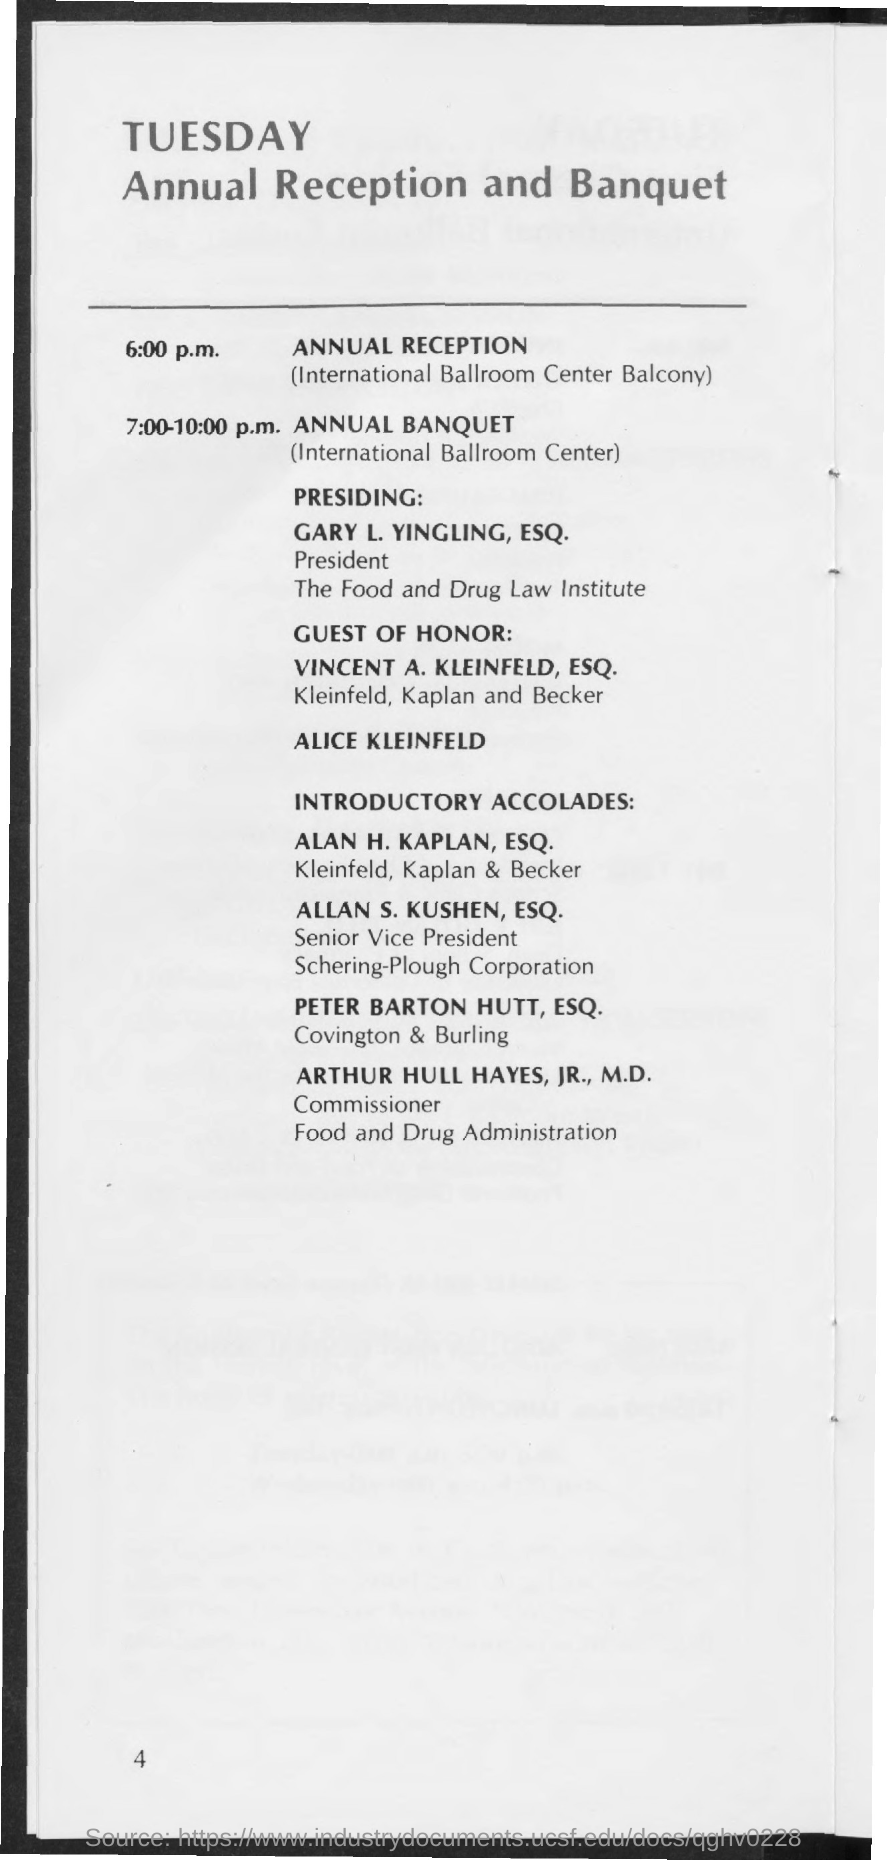Give some essential details in this illustration. The Annual Reception is scheduled to take place in the International Ballroom Center and on the balcony. The Annual Banquet has been scheduled to take place from 7:00-10:00 p.m. The name of the person presiding over the event is Gary L. Yingling, Esq. The ANNUAL BANQUET will take place in the International Ballroom Center. The Annual Reception is scheduled to begin at 6:00 p.m. 